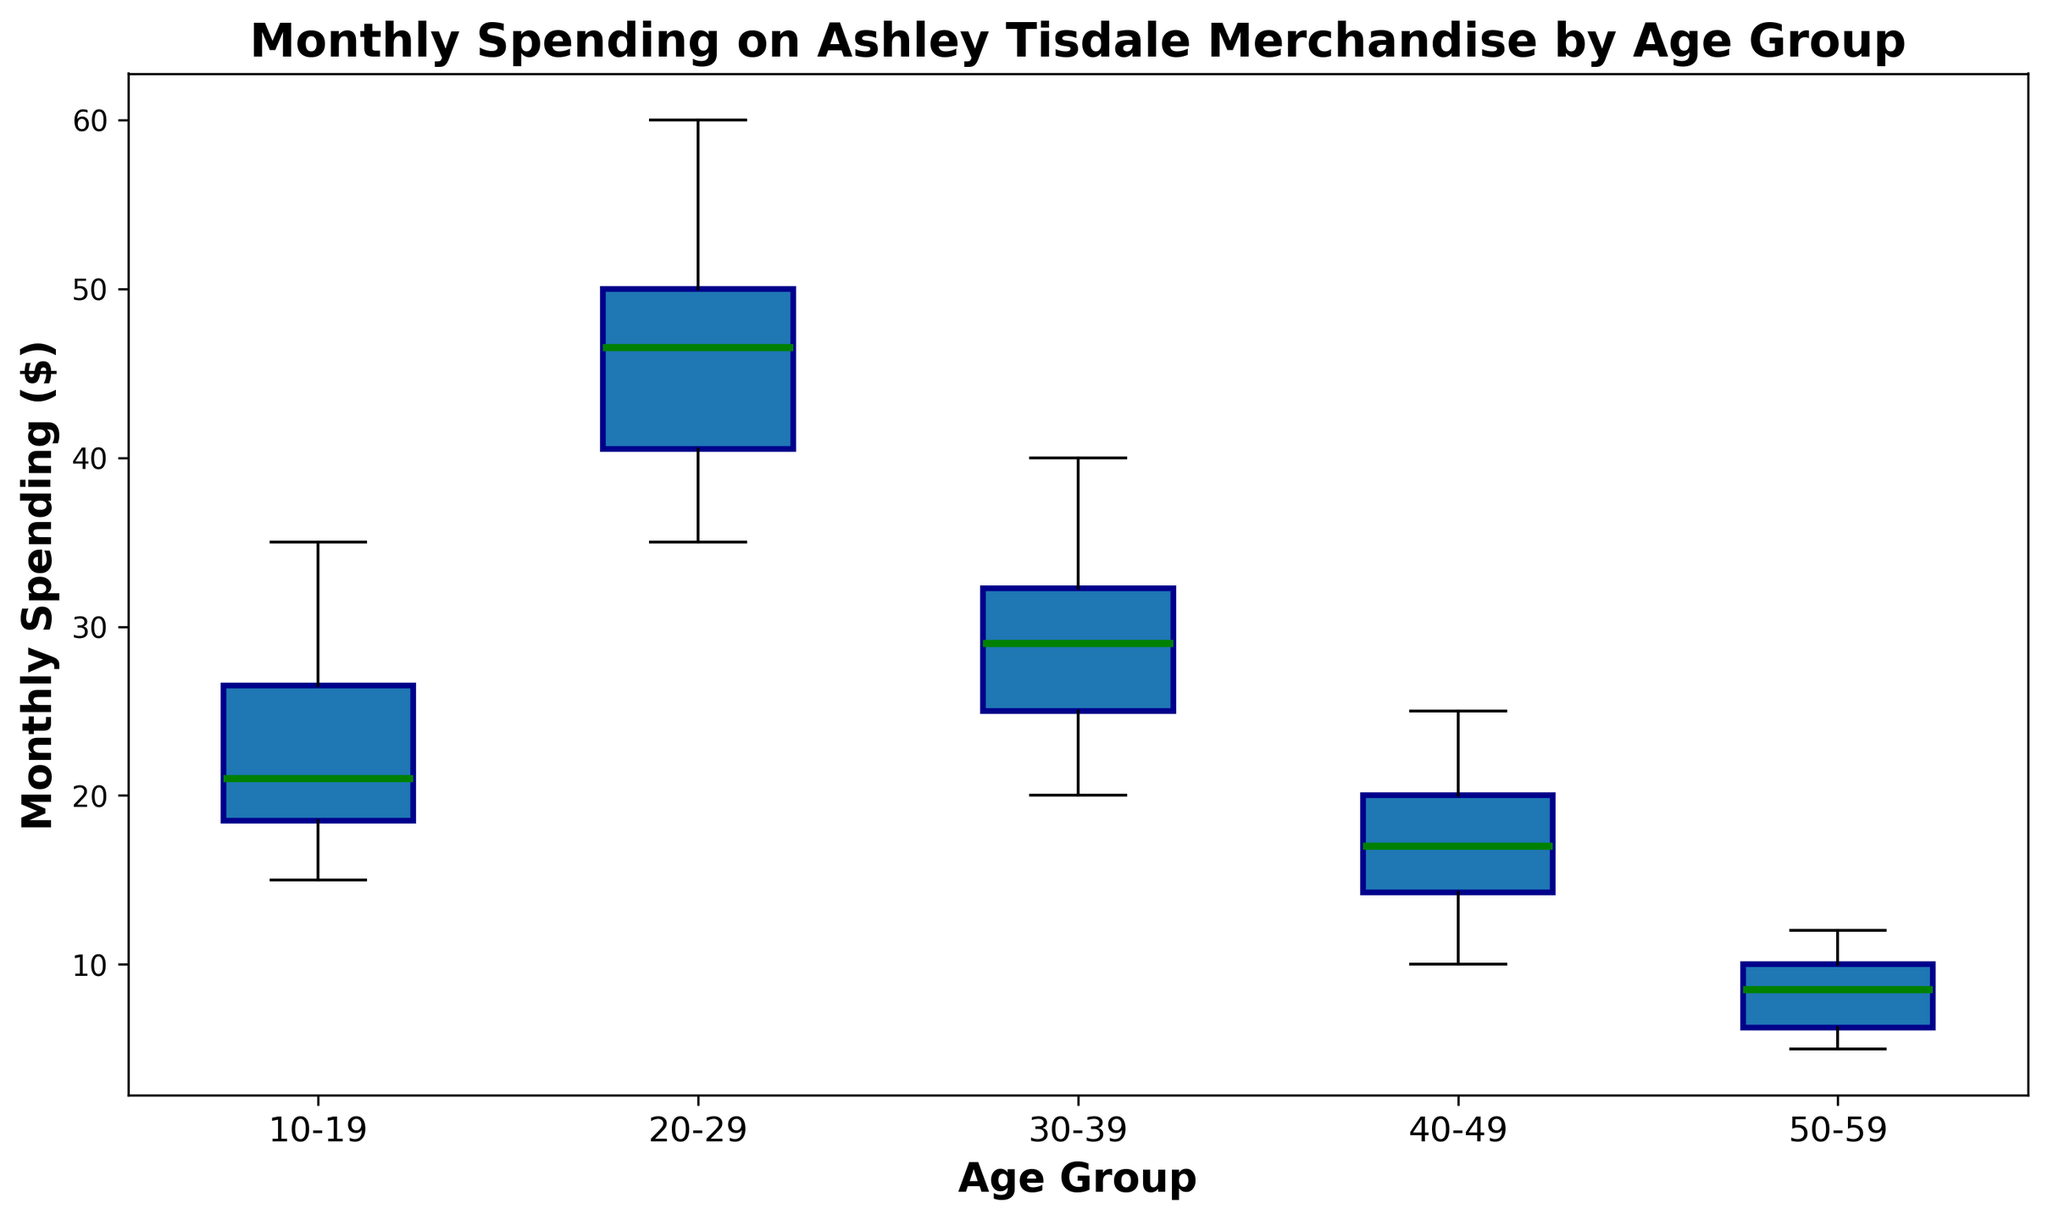Which age group has the highest median monthly spending on Ashley Tisdale merchandise? To find the age group with the highest median spending, identify the green lines (medians) for each boxplot and compare their positions. The highest median line appears in the 20-29 age group.
Answer: 20-29 What is the median monthly spending for the 30-39 age group? Look at the green line (median) inside the box for the 30-39 age group. The green line is at $30.
Answer: $30 Which age group has the smallest range of monthly spending on Ashley Tisdale merchandise? The range can be determined by the distance between the top and bottom of the blue boxes (interquartile range). The 50-59 age group shows the smallest range.
Answer: 50-59 How does the median spending of the 10-19 age group compare to the median spending of the 40-49 age group? Compare the positions of the green lines (medians). The median for the 10-19 age group is higher than the median for the 40-49 age group.
Answer: Higher In the 20-29 age group, what is the difference between the highest spending and the median spending? Identify the top whisker (highest point) and the green line (median) for the 20-29 age group. The highest spending is $60 and the median is $45, so the difference is $60 - $45 = $15.
Answer: $15 What is the interquartile range (IQR) for the 40-49 age group? The IQR is the distance between the top (75th percentile) and bottom (25th percentile) of the box. For the 40-49 age group, the bottom of the box is at $14 and the top is at $20. Thus, the IQR is $20 - $14 = $6.
Answer: $6 Which age group shows the maximum outliers in monthly spending? Outliers are identified by the small red circles outside the whiskers. Both 30-39 and 40-49 age groups show some outliers, but 50-59 has the maximal distinct outliers (many small red circles above the whiskers).
Answer: 50-59 What age group has the lowest maximum monthly spending? Maximum spending is indicated by the top whiskers for each boxplot. The lowest whisker is for the 50-59 age group.
Answer: 50-59 Is there any age group without any outliers in monthly spending? Outliers are shown as small red circles. The 10-19 and 20-29 age groups do not have any red circles outside their whiskers.
Answer: 10-19, 20-29 